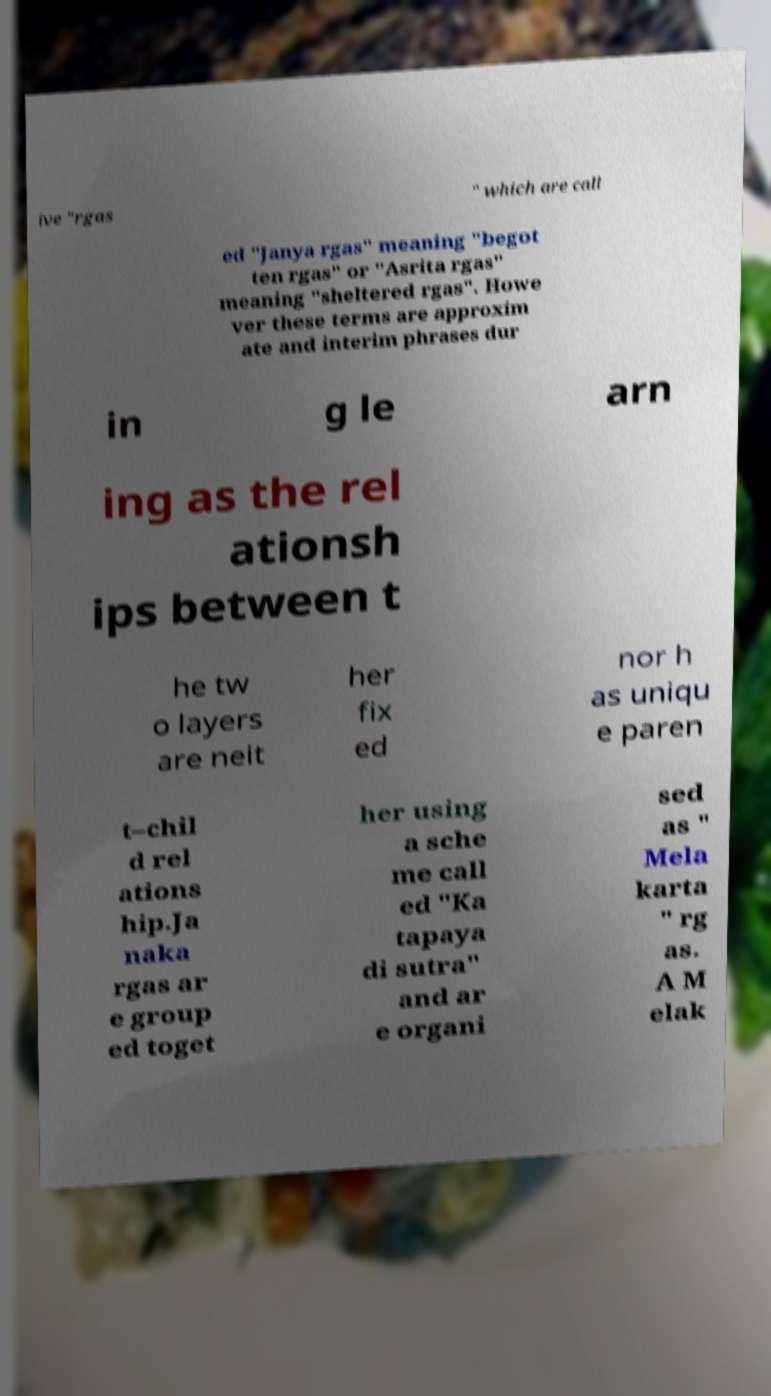Could you extract and type out the text from this image? ive "rgas " which are call ed "Janya rgas" meaning "begot ten rgas" or "Asrita rgas" meaning "sheltered rgas". Howe ver these terms are approxim ate and interim phrases dur in g le arn ing as the rel ationsh ips between t he tw o layers are neit her fix ed nor h as uniqu e paren t–chil d rel ations hip.Ja naka rgas ar e group ed toget her using a sche me call ed "Ka tapaya di sutra" and ar e organi sed as " Mela karta " rg as. A M elak 